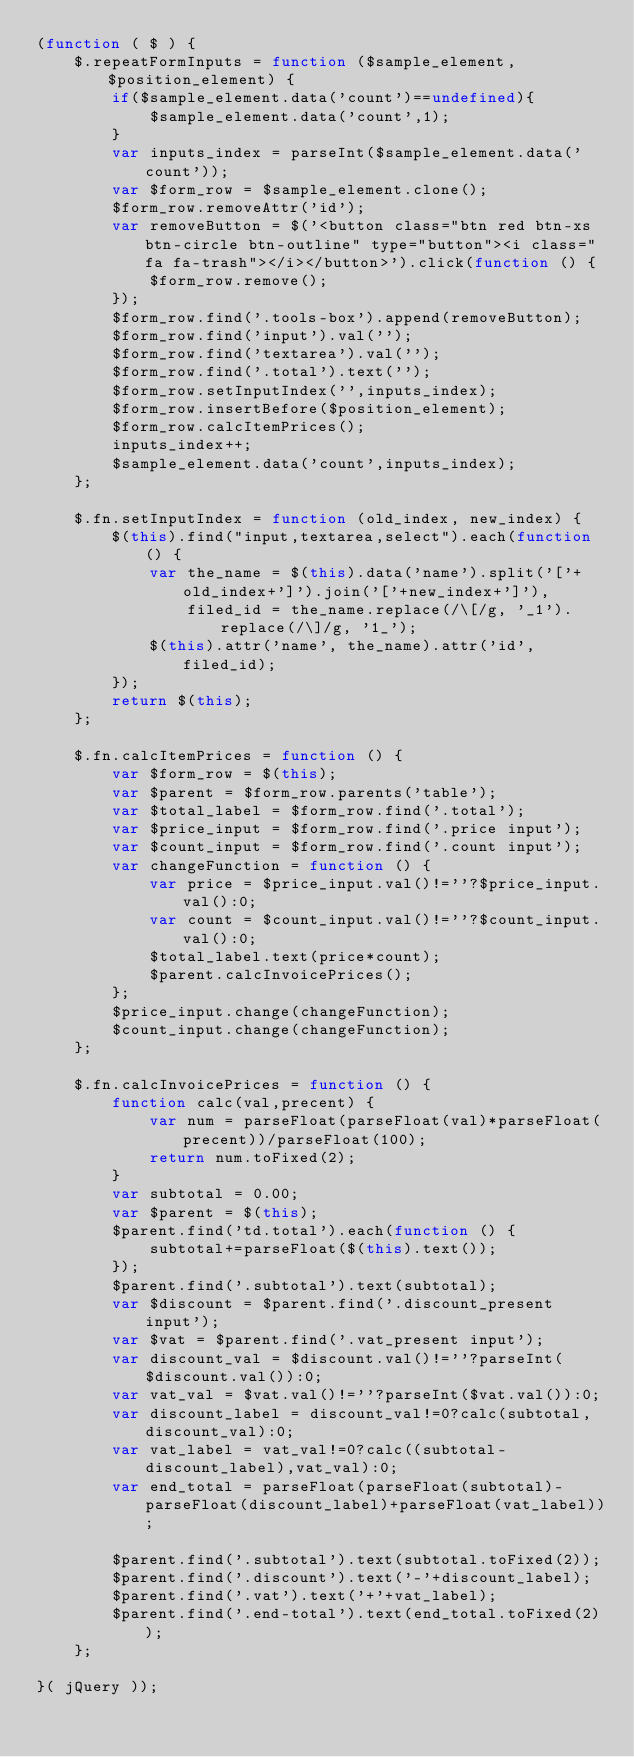Convert code to text. <code><loc_0><loc_0><loc_500><loc_500><_JavaScript_>(function ( $ ) {
    $.repeatFormInputs = function ($sample_element, $position_element) {
        if($sample_element.data('count')==undefined){
            $sample_element.data('count',1);
        }
        var inputs_index = parseInt($sample_element.data('count'));
        var $form_row = $sample_element.clone();
        $form_row.removeAttr('id');
        var removeButton = $('<button class="btn red btn-xs btn-circle btn-outline" type="button"><i class="fa fa-trash"></i></button>').click(function () {
            $form_row.remove();
        });
        $form_row.find('.tools-box').append(removeButton);
        $form_row.find('input').val('');
        $form_row.find('textarea').val('');
        $form_row.find('.total').text('');
        $form_row.setInputIndex('',inputs_index);
        $form_row.insertBefore($position_element);
        $form_row.calcItemPrices();
        inputs_index++;
        $sample_element.data('count',inputs_index);
    };

    $.fn.setInputIndex = function (old_index, new_index) {
        $(this).find("input,textarea,select").each(function () {
            var the_name = $(this).data('name').split('['+old_index+']').join('['+new_index+']'),
                filed_id = the_name.replace(/\[/g, '_1').replace(/\]/g, '1_');
            $(this).attr('name', the_name).attr('id', filed_id);
        });
        return $(this);
    };

    $.fn.calcItemPrices = function () {
        var $form_row = $(this);
        var $parent = $form_row.parents('table');
        var $total_label = $form_row.find('.total');
        var $price_input = $form_row.find('.price input');
        var $count_input = $form_row.find('.count input');
        var changeFunction = function () {
            var price = $price_input.val()!=''?$price_input.val():0;
            var count = $count_input.val()!=''?$count_input.val():0;
            $total_label.text(price*count);
            $parent.calcInvoicePrices();
        };
        $price_input.change(changeFunction);
        $count_input.change(changeFunction);
    };

    $.fn.calcInvoicePrices = function () {
        function calc(val,precent) {
            var num = parseFloat(parseFloat(val)*parseFloat(precent))/parseFloat(100);
            return num.toFixed(2);
        }
        var subtotal = 0.00;
        var $parent = $(this);
        $parent.find('td.total').each(function () {
            subtotal+=parseFloat($(this).text());
        });
        $parent.find('.subtotal').text(subtotal);
        var $discount = $parent.find('.discount_present input');
        var $vat = $parent.find('.vat_present input');
        var discount_val = $discount.val()!=''?parseInt($discount.val()):0;
        var vat_val = $vat.val()!=''?parseInt($vat.val()):0;
        var discount_label = discount_val!=0?calc(subtotal,discount_val):0;
        var vat_label = vat_val!=0?calc((subtotal-discount_label),vat_val):0;
        var end_total = parseFloat(parseFloat(subtotal)-parseFloat(discount_label)+parseFloat(vat_label));

        $parent.find('.subtotal').text(subtotal.toFixed(2));
        $parent.find('.discount').text('-'+discount_label);
        $parent.find('.vat').text('+'+vat_label);
        $parent.find('.end-total').text(end_total.toFixed(2));
    };

}( jQuery ));</code> 